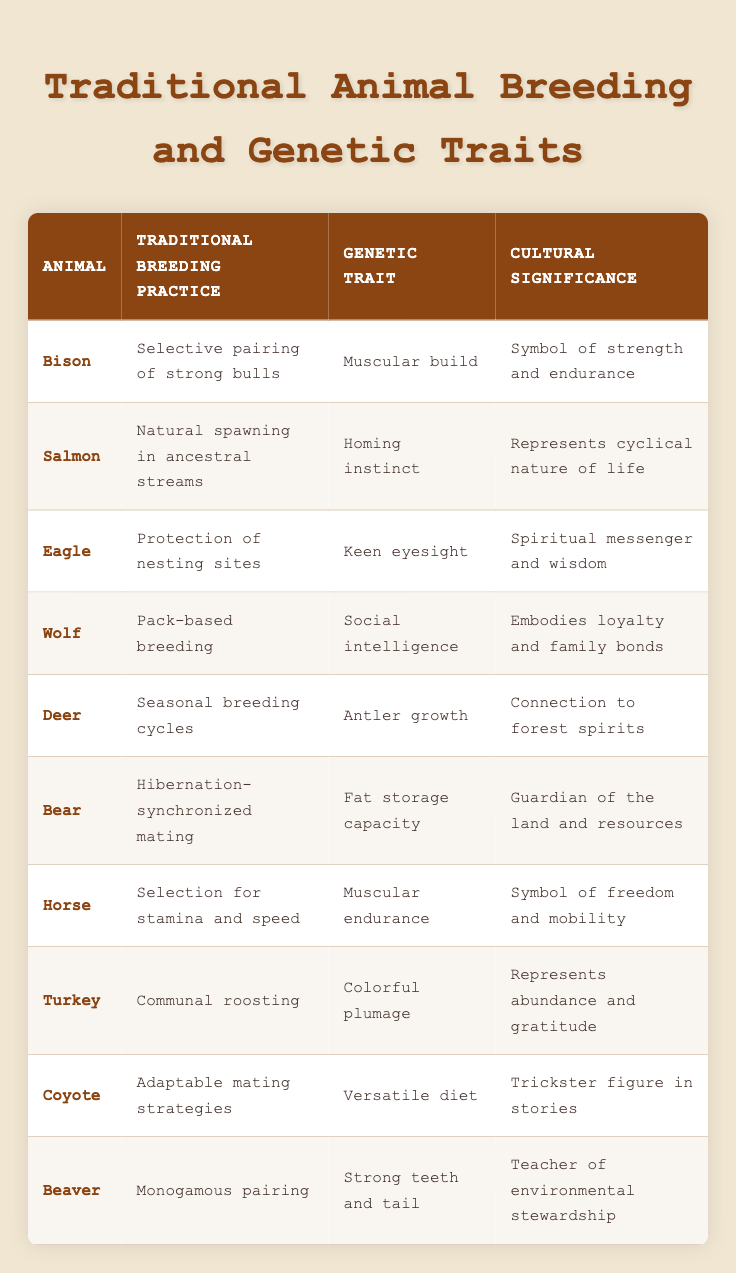What is the traditional breeding practice for bison? According to the table, the traditional breeding practice for bison is selective pairing of strong bulls.
Answer: Selective pairing of strong bulls What genetic trait is associated with salmon? The table indicates that the genetic trait associated with salmon is the homing instinct.
Answer: Homing instinct Is the eagle protected in traditional breeding practices? Yes, the table mentions that the traditional breeding practice includes the protection of nesting sites for eagles.
Answer: Yes Which animal's breeding practice emphasizes social intelligence? The table shows that the wolf's breeding practice, which is pack-based breeding, emphasizes social intelligence.
Answer: Wolf What are the cultural significance and genetic trait of the turkey? The table states that the turkey is associated with colorful plumage as a genetic trait and its cultural significance represents abundance and gratitude.
Answer: Colorful plumage; represents abundance and gratitude How many animals have a connection to spiritual or cultural values as stated in the table? Five animals are explicitly linked to spiritual or cultural values based on their cultural significance: bison, eagle, deer, bear, and turkey.
Answer: Five Does the bear's breeding practice have any relation to its fat storage capacity? Yes, the table explains that the bear's hibernation-synchronized mating relates directly to its genetic trait of fat storage capacity.
Answer: Yes Which animal has the strongest genetic trait of social intelligence and what practice supports it? The wolf exhibits the strongest genetic trait of social intelligence, supported by the traditional breeding practice of pack-based breeding as indicated in the table.
Answer: Wolf; pack-based breeding What would be the average number of genetic traits associated with animals in this table? Counting each unique genetic trait from the ten rows gives a total of ten traits. Therefore, the average is 10/10 = 1, as each animal has one trait associated with it.
Answer: 1 Which animals share traits associated with endurance or strength? Bison and horse share traits related to endurance or strength; bison is noted for muscular build, while the horse is recognized for muscular endurance.
Answer: Bison; Horse 